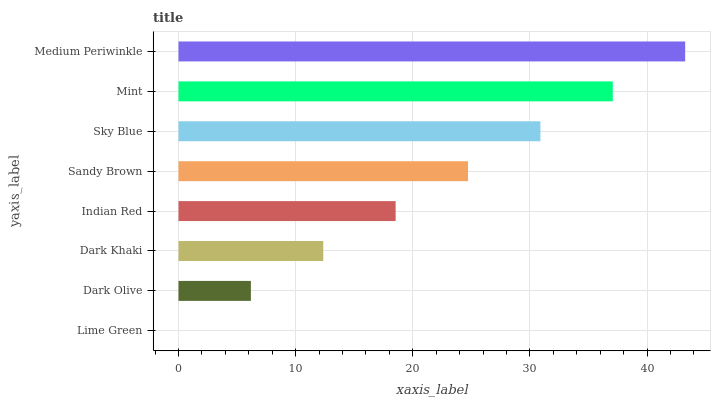Is Lime Green the minimum?
Answer yes or no. Yes. Is Medium Periwinkle the maximum?
Answer yes or no. Yes. Is Dark Olive the minimum?
Answer yes or no. No. Is Dark Olive the maximum?
Answer yes or no. No. Is Dark Olive greater than Lime Green?
Answer yes or no. Yes. Is Lime Green less than Dark Olive?
Answer yes or no. Yes. Is Lime Green greater than Dark Olive?
Answer yes or no. No. Is Dark Olive less than Lime Green?
Answer yes or no. No. Is Sandy Brown the high median?
Answer yes or no. Yes. Is Indian Red the low median?
Answer yes or no. Yes. Is Dark Olive the high median?
Answer yes or no. No. Is Lime Green the low median?
Answer yes or no. No. 